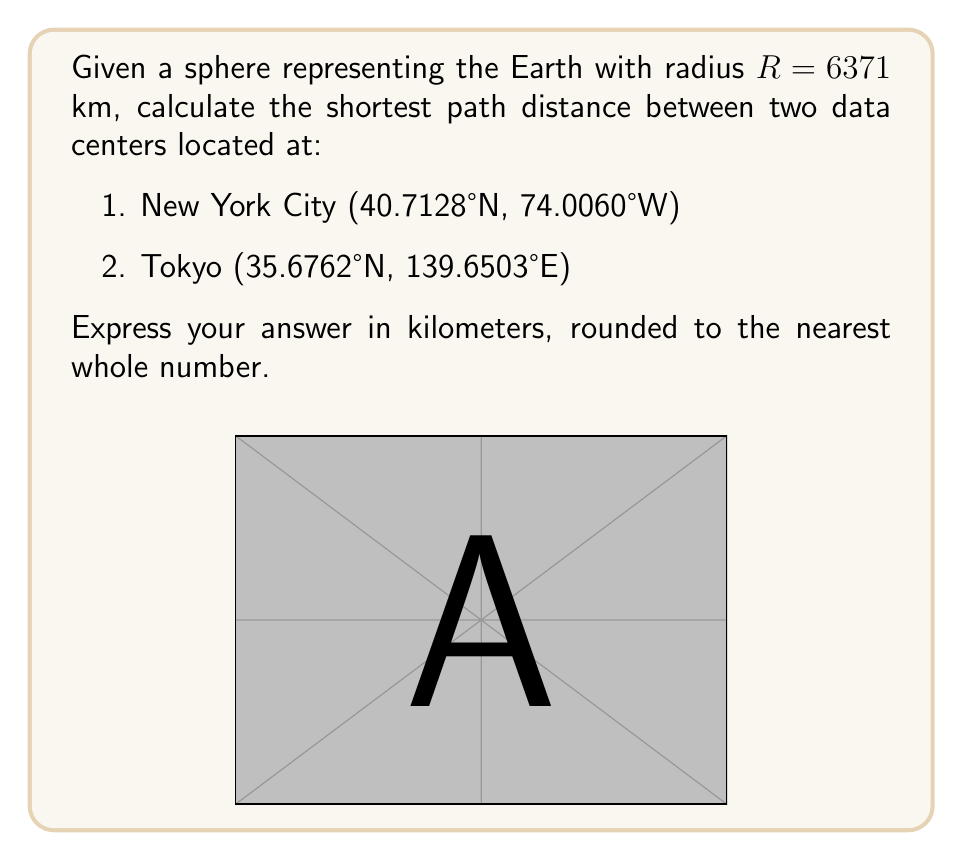Provide a solution to this math problem. To solve this problem, we'll use the great-circle distance formula, which gives the shortest path between two points on a sphere. This is particularly relevant for optimizing global network routing in serverless architectures. The steps are as follows:

1. Convert the latitudes and longitudes to radians:
   NYC: $\phi_1 = 40.7128° \times \frac{\pi}{180} = 0.7104$ rad
        $\lambda_1 = -74.0060° \times \frac{\pi}{180} = -1.2917$ rad
   Tokyo: $\phi_2 = 35.6762° \times \frac{\pi}{180} = 0.6227$ rad
          $\lambda_2 = 139.6503° \times \frac{\pi}{180} = 2.4372$ rad

2. Calculate the central angle $\Delta\sigma$ using the Haversine formula:
   $$\Delta\sigma = 2 \arcsin\left(\sqrt{\sin^2\left(\frac{\phi_2 - \phi_1}{2}\right) + \cos\phi_1 \cos\phi_2 \sin^2\left(\frac{\lambda_2 - \lambda_1}{2}\right)}\right)$$

3. Substitute the values:
   $$\Delta\sigma = 2 \arcsin\left(\sqrt{\sin^2\left(\frac{0.6227 - 0.7104}{2}\right) + \cos(0.7104) \cos(0.6227) \sin^2\left(\frac{2.4372 - (-1.2917)}{2}\right)}\right)$$

4. Calculate:
   $$\Delta\sigma = 2 \arcsin(\sqrt{0.0019 + 0.7533 \times 0.7799 \times 0.8995})$$
   $$\Delta\sigma = 2 \arcsin(\sqrt{0.5297}) = 2 \arcsin(0.7278) = 1.6232$$

5. The distance $d$ is then calculated by multiplying the central angle by the Earth's radius:
   $$d = R \times \Delta\sigma = 6371 \times 1.6232 = 10341.7 \text{ km}$$

6. Rounding to the nearest whole number:
   $$d \approx 10342 \text{ km}$$

This calculation demonstrates how to optimize routing for global serverless architectures by determining the shortest path between two points on Earth's surface.
Answer: 10342 km 